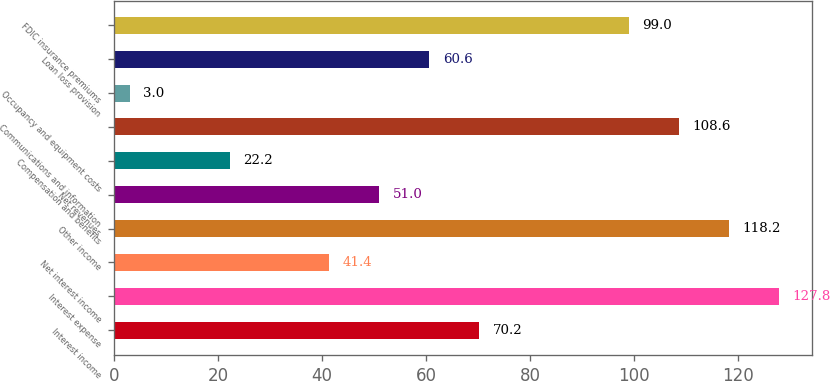Convert chart to OTSL. <chart><loc_0><loc_0><loc_500><loc_500><bar_chart><fcel>Interest income<fcel>Interest expense<fcel>Net interest income<fcel>Other income<fcel>Net revenues<fcel>Compensation and benefits<fcel>Communications and information<fcel>Occupancy and equipment costs<fcel>Loan loss provision<fcel>FDIC insurance premiums<nl><fcel>70.2<fcel>127.8<fcel>41.4<fcel>118.2<fcel>51<fcel>22.2<fcel>108.6<fcel>3<fcel>60.6<fcel>99<nl></chart> 